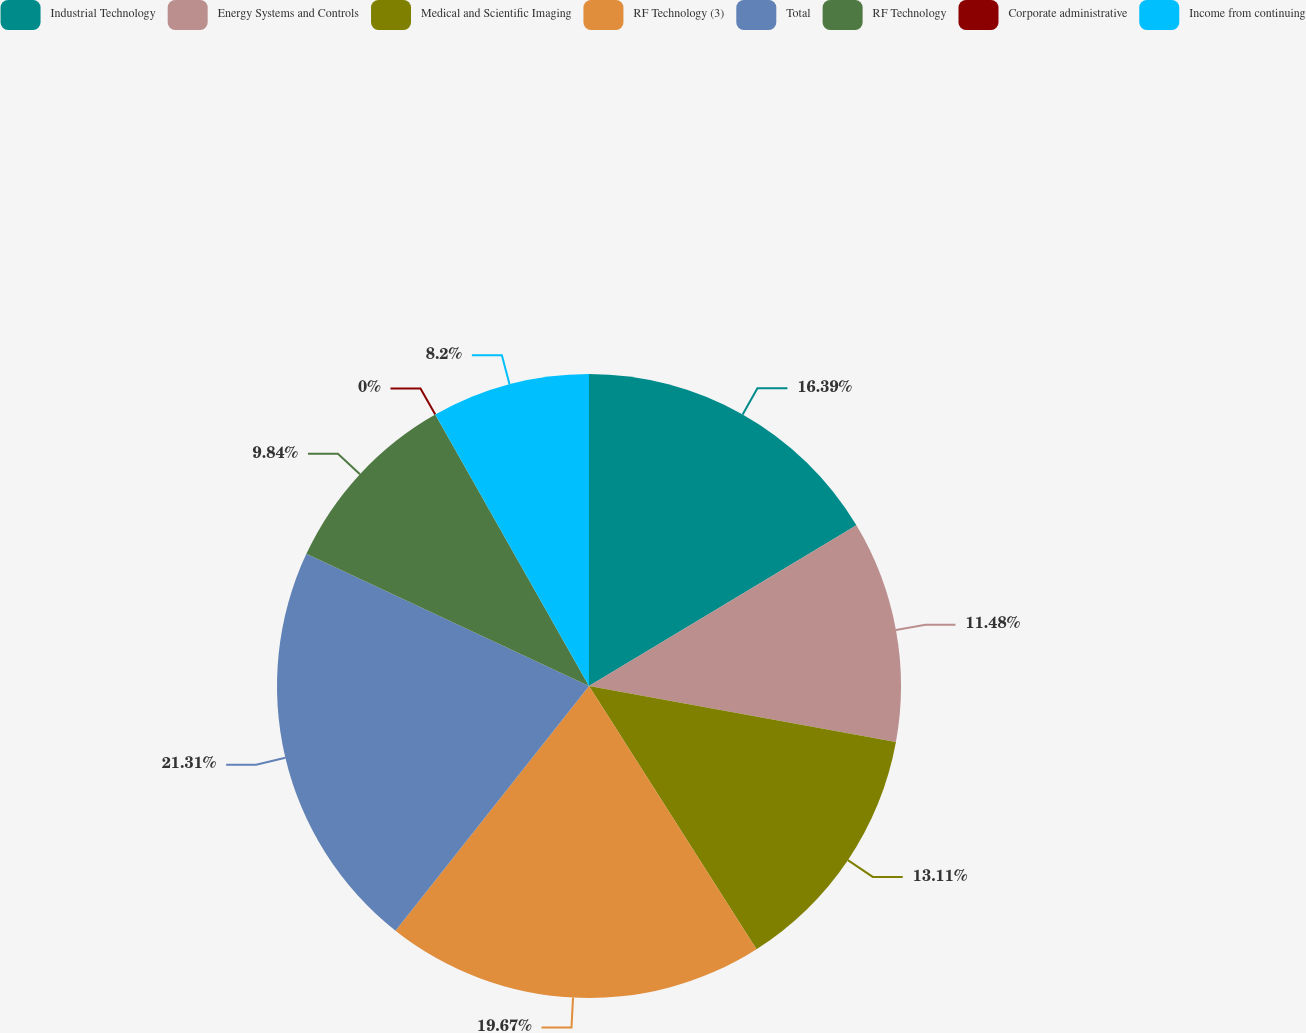Convert chart to OTSL. <chart><loc_0><loc_0><loc_500><loc_500><pie_chart><fcel>Industrial Technology<fcel>Energy Systems and Controls<fcel>Medical and Scientific Imaging<fcel>RF Technology (3)<fcel>Total<fcel>RF Technology<fcel>Corporate administrative<fcel>Income from continuing<nl><fcel>16.39%<fcel>11.48%<fcel>13.11%<fcel>19.67%<fcel>21.31%<fcel>9.84%<fcel>0.0%<fcel>8.2%<nl></chart> 